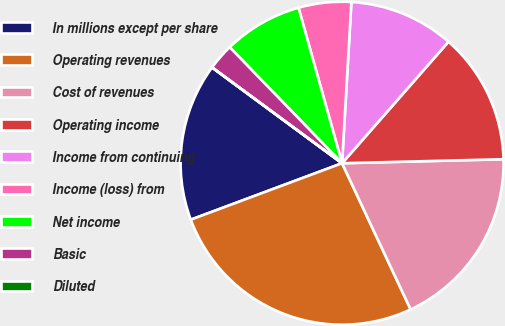<chart> <loc_0><loc_0><loc_500><loc_500><pie_chart><fcel>In millions except per share<fcel>Operating revenues<fcel>Cost of revenues<fcel>Operating income<fcel>Income from continuing<fcel>Income (loss) from<fcel>Net income<fcel>Basic<fcel>Diluted<nl><fcel>15.79%<fcel>26.3%<fcel>18.42%<fcel>13.16%<fcel>10.53%<fcel>5.27%<fcel>7.9%<fcel>2.64%<fcel>0.01%<nl></chart> 